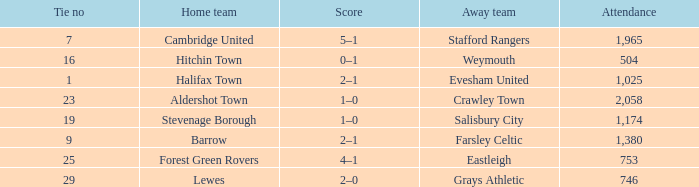How many attended tie number 19? 1174.0. 